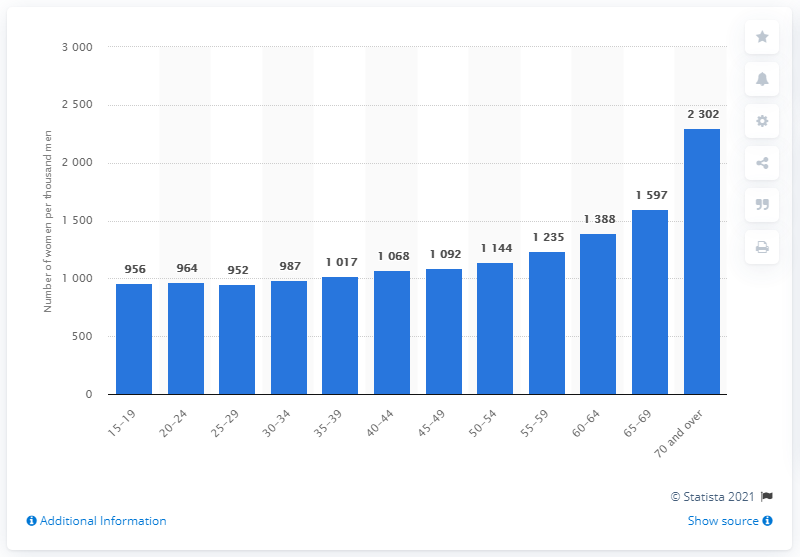Identify some key points in this picture. According to data from 15 to 19-year-old Russians, the lowest female to male ratio was 956. 